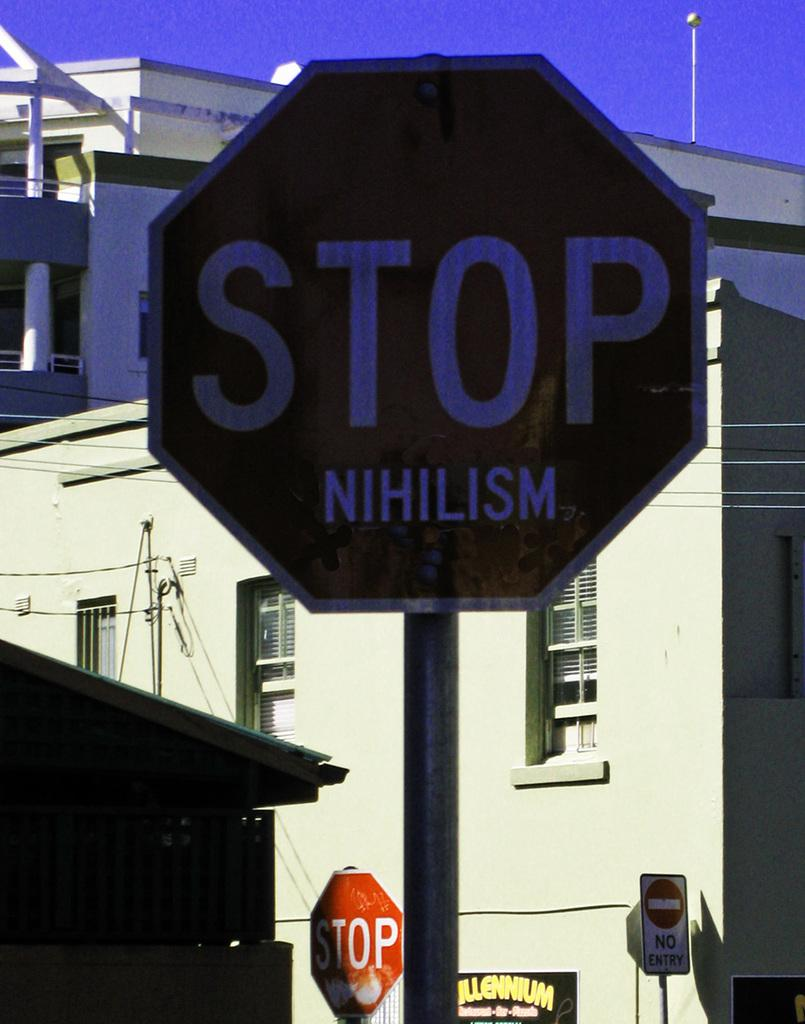<image>
Describe the image concisely. The stop sign has the word Nihilism written below it. 